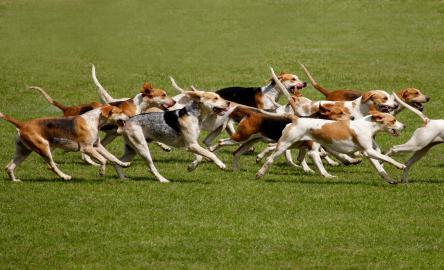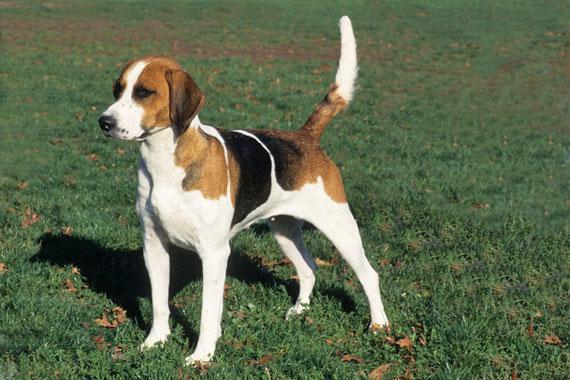The first image is the image on the left, the second image is the image on the right. For the images shown, is this caption "A persons leg is visible in the right image." true? Answer yes or no. No. The first image is the image on the left, the second image is the image on the right. For the images shown, is this caption "In one image, all dogs are running in a field." true? Answer yes or no. Yes. 